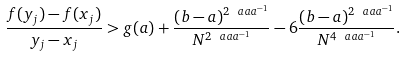<formula> <loc_0><loc_0><loc_500><loc_500>\frac { f ( y _ { j } ) - f ( x _ { j } ) } { y _ { j } - x _ { j } } > g ( a ) + \frac { ( b - a ) ^ { 2 \ a a a ^ { - 1 } } } { N ^ { 2 \ a a a ^ { - 1 } } } - 6 \frac { ( b - a ) ^ { 2 \ a a a ^ { - 1 } } } { N ^ { 4 \ a a a ^ { - 1 } } } .</formula> 